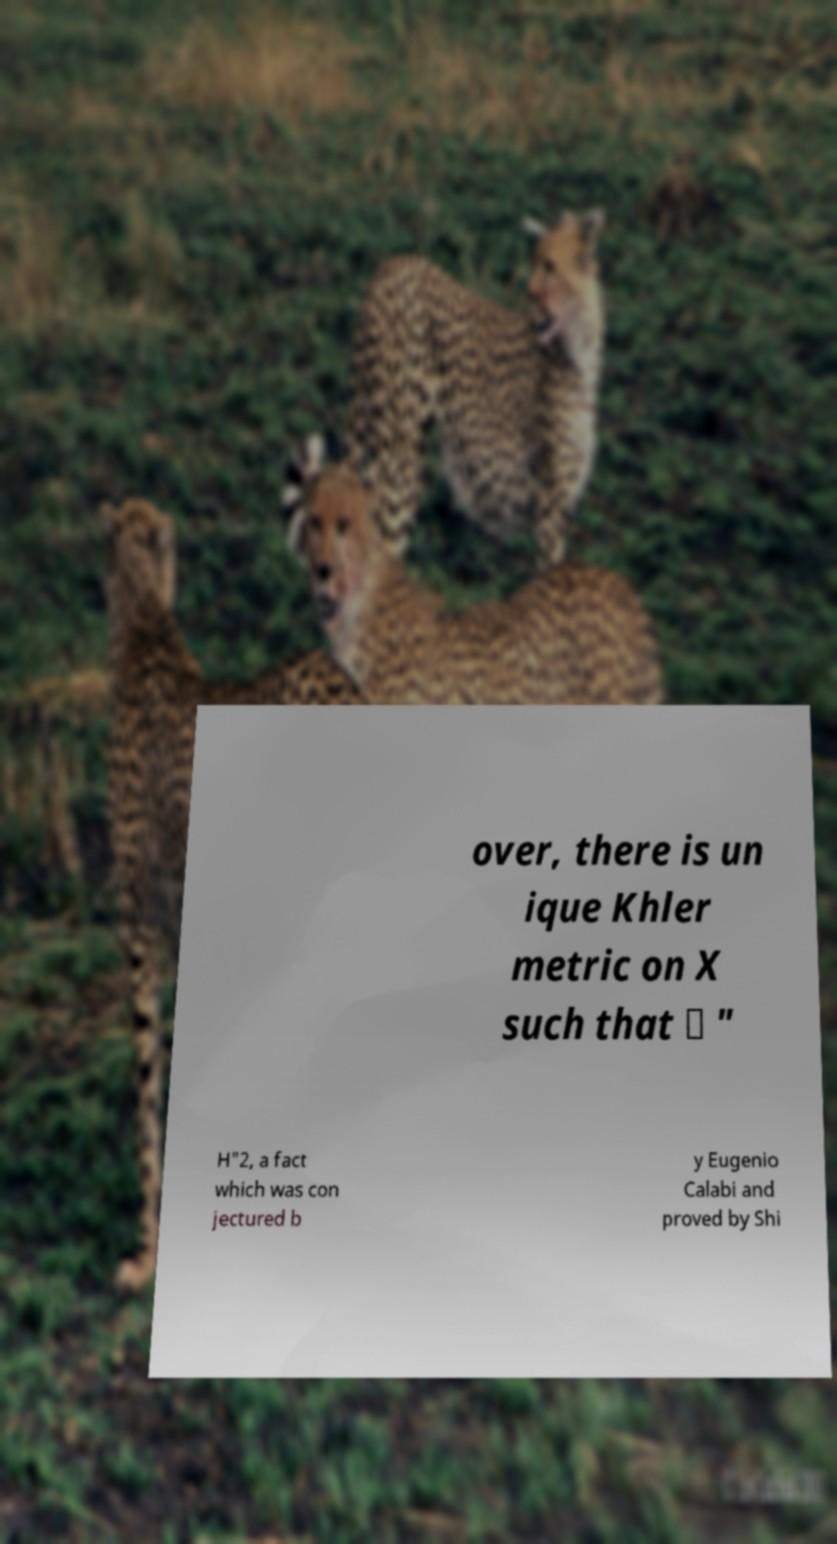Can you read and provide the text displayed in the image?This photo seems to have some interesting text. Can you extract and type it out for me? over, there is un ique Khler metric on X such that ∈ " H"2, a fact which was con jectured b y Eugenio Calabi and proved by Shi 